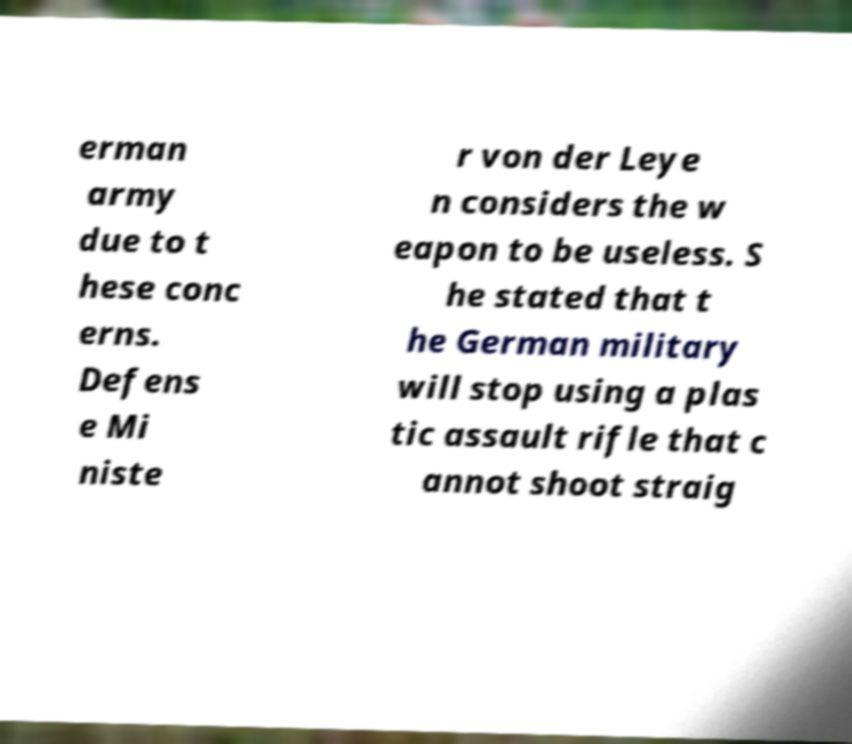Could you assist in decoding the text presented in this image and type it out clearly? erman army due to t hese conc erns. Defens e Mi niste r von der Leye n considers the w eapon to be useless. S he stated that t he German military will stop using a plas tic assault rifle that c annot shoot straig 